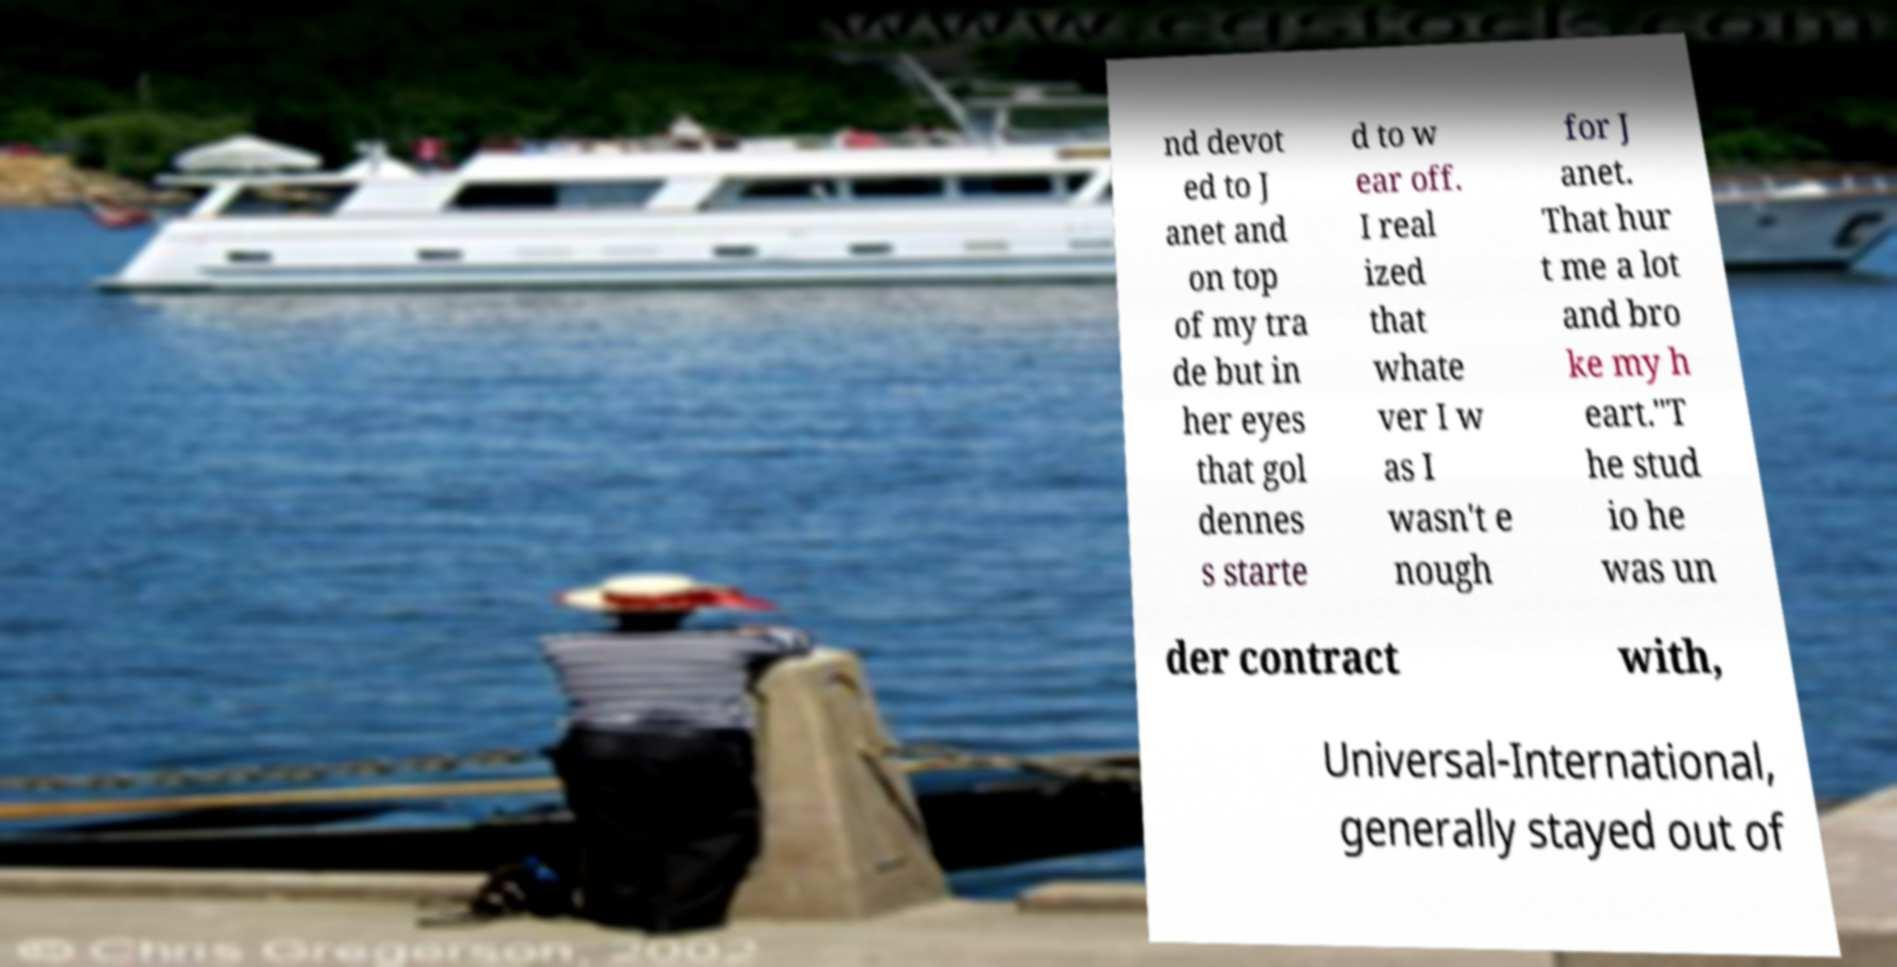Could you extract and type out the text from this image? nd devot ed to J anet and on top of my tra de but in her eyes that gol dennes s starte d to w ear off. I real ized that whate ver I w as I wasn't e nough for J anet. That hur t me a lot and bro ke my h eart."T he stud io he was un der contract with, Universal-International, generally stayed out of 